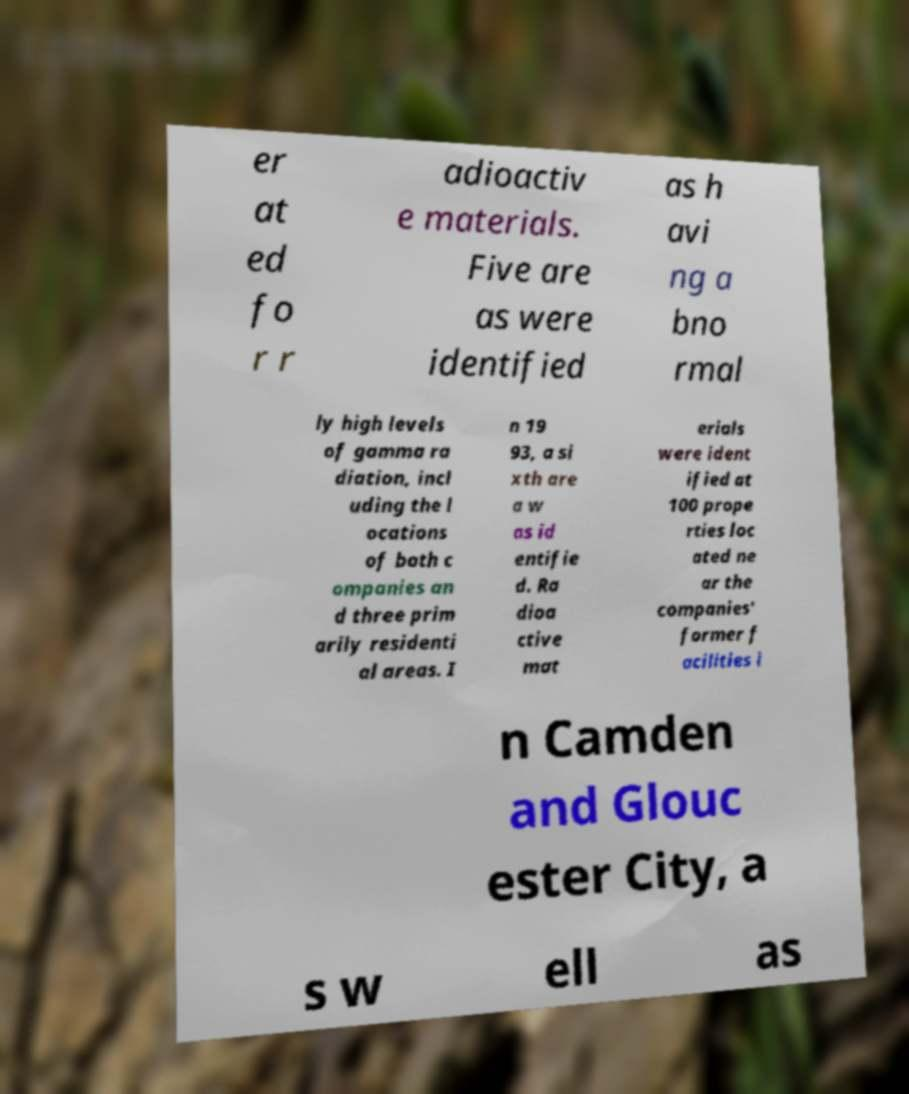Could you assist in decoding the text presented in this image and type it out clearly? er at ed fo r r adioactiv e materials. Five are as were identified as h avi ng a bno rmal ly high levels of gamma ra diation, incl uding the l ocations of both c ompanies an d three prim arily residenti al areas. I n 19 93, a si xth are a w as id entifie d. Ra dioa ctive mat erials were ident ified at 100 prope rties loc ated ne ar the companies' former f acilities i n Camden and Glouc ester City, a s w ell as 